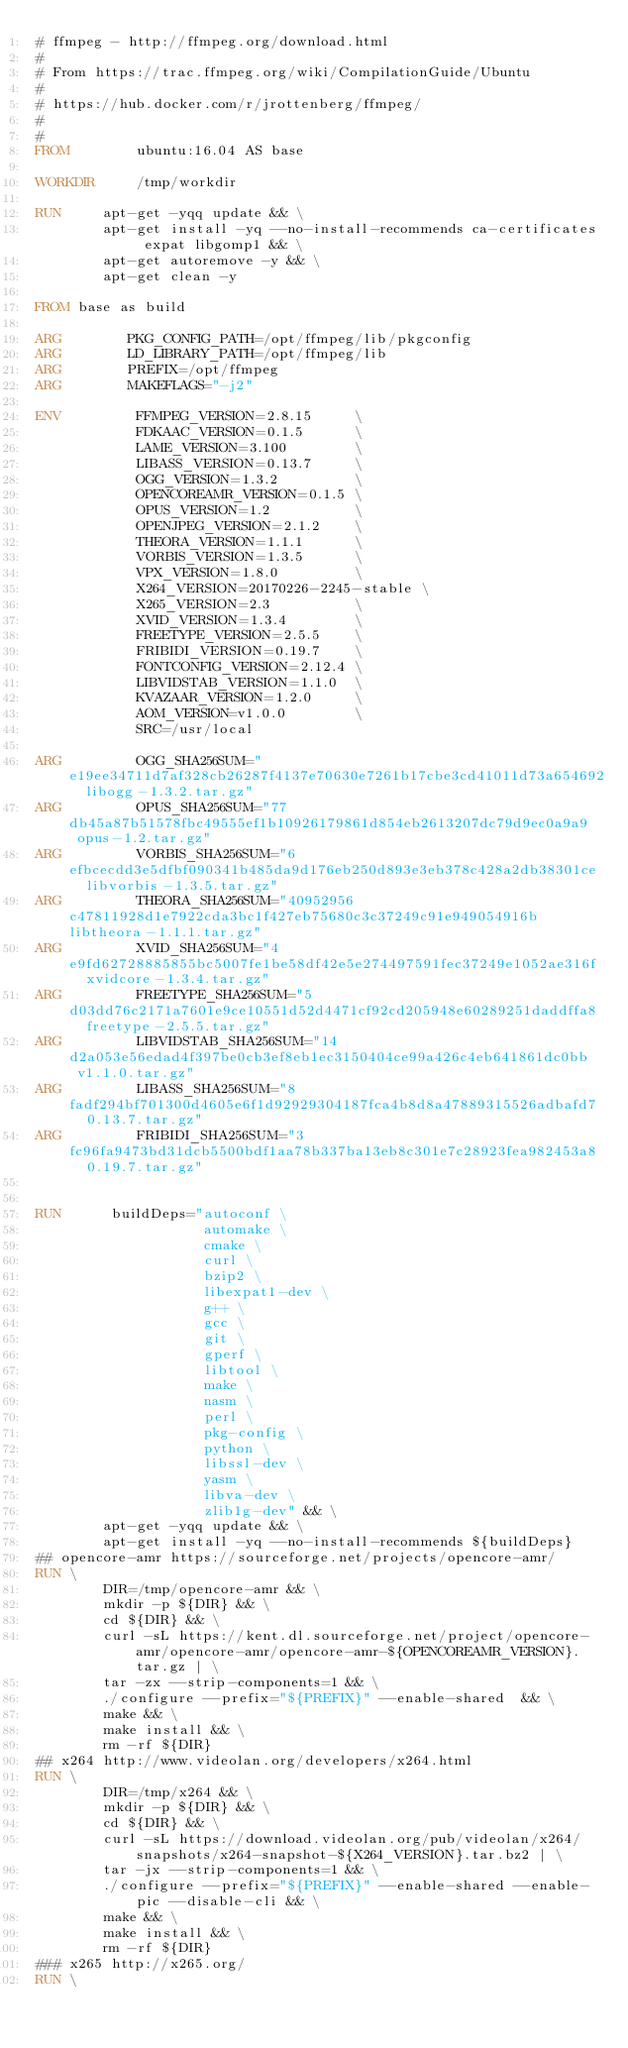<code> <loc_0><loc_0><loc_500><loc_500><_Dockerfile_># ffmpeg - http://ffmpeg.org/download.html
#
# From https://trac.ffmpeg.org/wiki/CompilationGuide/Ubuntu
#
# https://hub.docker.com/r/jrottenberg/ffmpeg/
#
#
FROM        ubuntu:16.04 AS base

WORKDIR     /tmp/workdir

RUN     apt-get -yqq update && \
        apt-get install -yq --no-install-recommends ca-certificates expat libgomp1 && \
        apt-get autoremove -y && \
        apt-get clean -y

FROM base as build

ARG        PKG_CONFIG_PATH=/opt/ffmpeg/lib/pkgconfig
ARG        LD_LIBRARY_PATH=/opt/ffmpeg/lib
ARG        PREFIX=/opt/ffmpeg
ARG        MAKEFLAGS="-j2"

ENV         FFMPEG_VERSION=2.8.15     \
            FDKAAC_VERSION=0.1.5      \
            LAME_VERSION=3.100        \
            LIBASS_VERSION=0.13.7     \
            OGG_VERSION=1.3.2         \
            OPENCOREAMR_VERSION=0.1.5 \
            OPUS_VERSION=1.2          \
            OPENJPEG_VERSION=2.1.2    \
            THEORA_VERSION=1.1.1      \
            VORBIS_VERSION=1.3.5      \
            VPX_VERSION=1.8.0         \
            X264_VERSION=20170226-2245-stable \
            X265_VERSION=2.3          \
            XVID_VERSION=1.3.4        \
            FREETYPE_VERSION=2.5.5    \
            FRIBIDI_VERSION=0.19.7    \
            FONTCONFIG_VERSION=2.12.4 \
            LIBVIDSTAB_VERSION=1.1.0  \
            KVAZAAR_VERSION=1.2.0     \
            AOM_VERSION=v1.0.0        \
            SRC=/usr/local

ARG         OGG_SHA256SUM="e19ee34711d7af328cb26287f4137e70630e7261b17cbe3cd41011d73a654692  libogg-1.3.2.tar.gz"
ARG         OPUS_SHA256SUM="77db45a87b51578fbc49555ef1b10926179861d854eb2613207dc79d9ec0a9a9  opus-1.2.tar.gz"
ARG         VORBIS_SHA256SUM="6efbcecdd3e5dfbf090341b485da9d176eb250d893e3eb378c428a2db38301ce  libvorbis-1.3.5.tar.gz"
ARG         THEORA_SHA256SUM="40952956c47811928d1e7922cda3bc1f427eb75680c3c37249c91e949054916b  libtheora-1.1.1.tar.gz"
ARG         XVID_SHA256SUM="4e9fd62728885855bc5007fe1be58df42e5e274497591fec37249e1052ae316f  xvidcore-1.3.4.tar.gz"
ARG         FREETYPE_SHA256SUM="5d03dd76c2171a7601e9ce10551d52d4471cf92cd205948e60289251daddffa8  freetype-2.5.5.tar.gz"
ARG         LIBVIDSTAB_SHA256SUM="14d2a053e56edad4f397be0cb3ef8eb1ec3150404ce99a426c4eb641861dc0bb  v1.1.0.tar.gz"
ARG         LIBASS_SHA256SUM="8fadf294bf701300d4605e6f1d92929304187fca4b8d8a47889315526adbafd7  0.13.7.tar.gz"
ARG         FRIBIDI_SHA256SUM="3fc96fa9473bd31dcb5500bdf1aa78b337ba13eb8c301e7c28923fea982453a8  0.19.7.tar.gz"


RUN      buildDeps="autoconf \
                    automake \
                    cmake \
                    curl \
                    bzip2 \
                    libexpat1-dev \
                    g++ \
                    gcc \
                    git \
                    gperf \
                    libtool \
                    make \
                    nasm \
                    perl \
                    pkg-config \
                    python \
                    libssl-dev \
                    yasm \
                    libva-dev \
                    zlib1g-dev" && \
        apt-get -yqq update && \
        apt-get install -yq --no-install-recommends ${buildDeps}
## opencore-amr https://sourceforge.net/projects/opencore-amr/
RUN \
        DIR=/tmp/opencore-amr && \
        mkdir -p ${DIR} && \
        cd ${DIR} && \
        curl -sL https://kent.dl.sourceforge.net/project/opencore-amr/opencore-amr/opencore-amr-${OPENCOREAMR_VERSION}.tar.gz | \
        tar -zx --strip-components=1 && \
        ./configure --prefix="${PREFIX}" --enable-shared  && \
        make && \
        make install && \
        rm -rf ${DIR}
## x264 http://www.videolan.org/developers/x264.html
RUN \
        DIR=/tmp/x264 && \
        mkdir -p ${DIR} && \
        cd ${DIR} && \
        curl -sL https://download.videolan.org/pub/videolan/x264/snapshots/x264-snapshot-${X264_VERSION}.tar.bz2 | \
        tar -jx --strip-components=1 && \
        ./configure --prefix="${PREFIX}" --enable-shared --enable-pic --disable-cli && \
        make && \
        make install && \
        rm -rf ${DIR}
### x265 http://x265.org/
RUN \</code> 